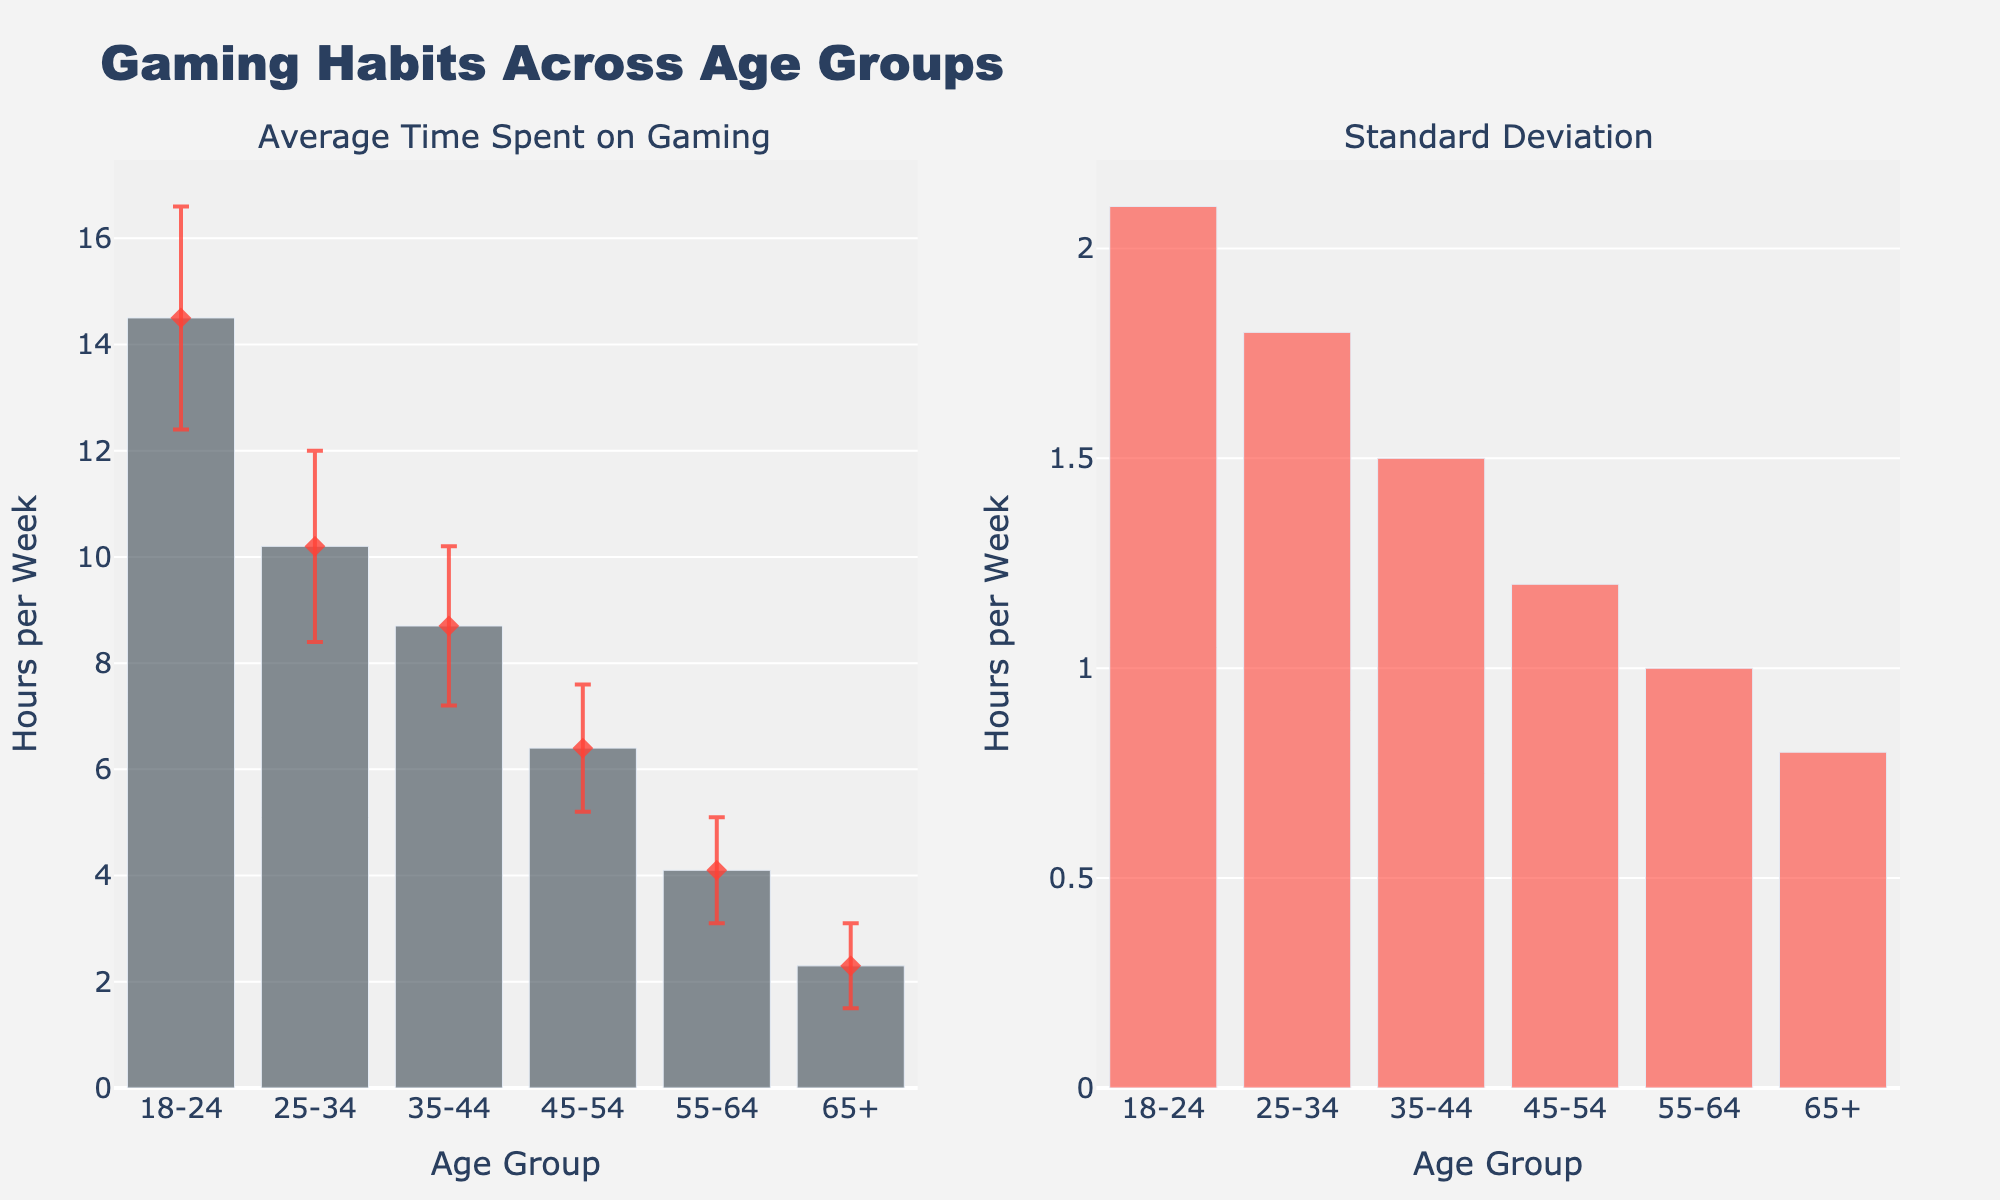What's the title of the figure? The title of the figure can be found at the top of the plot. It reads "Gaming Habits Across Age Groups".
Answer: Gaming Habits Across Age Groups What does the x-axis represent in the first subplot? The x-axis in the first subplot lists the age groups being analyzed, which are "18-24", "25-34", "35-44", "45-54", "55-64", and "65+".
Answer: Age Group Which age group spends the most time gaming on average? By looking at the heights of the bars in the first subplot, the "18-24" age group has the highest bar, indicating that this age group spends the most time gaming on average.
Answer: 18-24 How many hours per week does the 45-54 age group spend on gaming on average? By checking the height of the bar corresponding to the "45-54" age group in the first subplot, the average time spent on gaming is 6.4 hours per week.
Answer: 6.4 hours/week Which age group has the largest standard deviation in their gaming time? In the second subplot showing standard deviation, the age group with the highest bar represents the largest standard deviation. This is the "18-24" age group.
Answer: 18-24 What is the difference in average hours spent on gaming between the 25-34 and 55-64 age groups? Referring to the bars in the first subplot, the 25-34 age group spends 10.2 hours/week while the 55-64 group spends 4.1 hours/week. The difference is 10.2 - 4.1 = 6.1 hours.
Answer: 6.1 hours How much is the error margin for the 35-44 age group? The length of the error bar in the first subplot signifies the standard deviation for the 35-44 age group, which is 1.5 hours.
Answer: 1.5 hours Are there more age groups above or below the mean gaming time of the 45-54 age group? The mean gaming time for the 45-54 age group is 6.4 hours/week. Comparing this with all other age groups by their bar heights in the first subplot: 18-24, 25-34, and 35-44 are above this mean, while 55-64 and 65+ are below. Therefore, there are more age groups above (3 groups above and 2 below).
Answer: More above What is the total average gaming time for all age groups combined? Summing up the average gaming times for all age groups: 14.5 (18-24) + 10.2 (25-34) + 8.7 (35-44) + 6.4 (45-54) + 4.1 (55-64) + 2.3 (65+) = 46.2 hours/week.
Answer: 46.2 hours/week 